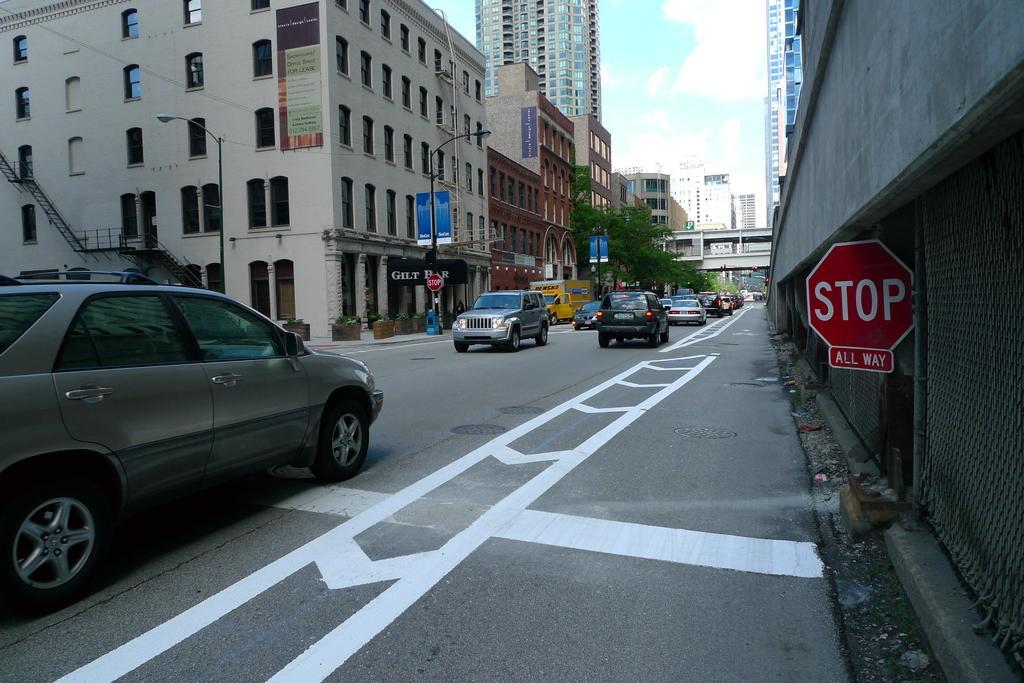Can you describe this image briefly? In the foreground I can see boards, fleets of vehicles on the road, buildings, light poles, windows and trees. In the background I can see a bridge and the sky. This image is taken may be during a day. 